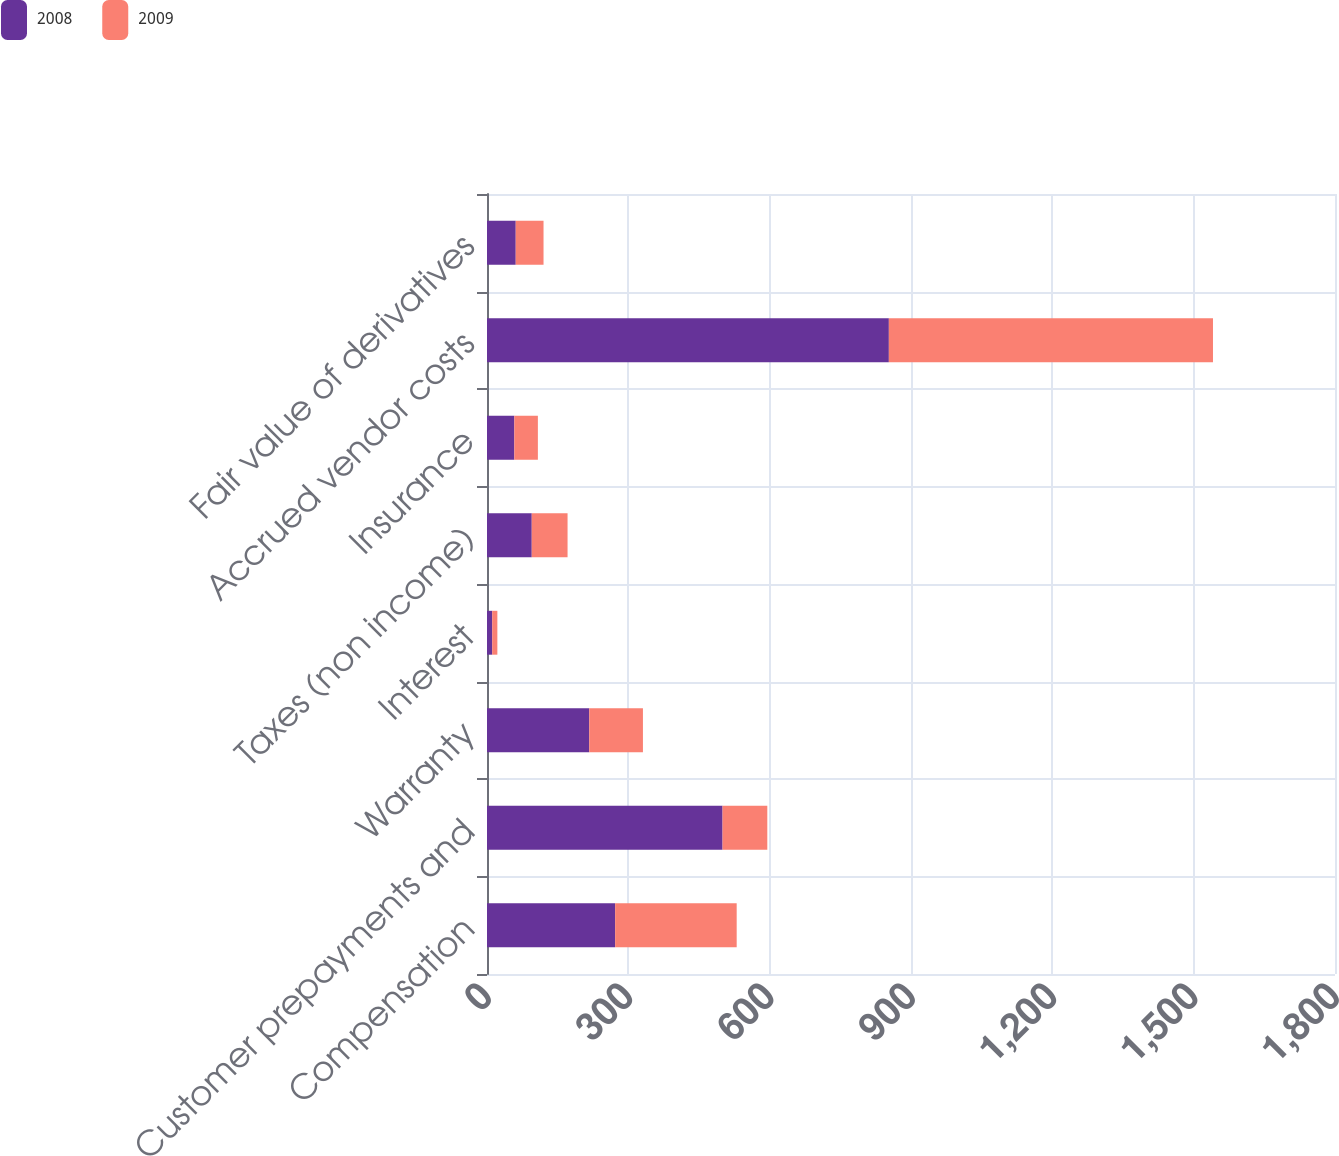Convert chart to OTSL. <chart><loc_0><loc_0><loc_500><loc_500><stacked_bar_chart><ecel><fcel>Compensation<fcel>Customer prepayments and<fcel>Warranty<fcel>Interest<fcel>Taxes (non income)<fcel>Insurance<fcel>Accrued vendor costs<fcel>Fair value of derivatives<nl><fcel>2008<fcel>272<fcel>500<fcel>217<fcel>11<fcel>95<fcel>58<fcel>853<fcel>61<nl><fcel>2009<fcel>258<fcel>95<fcel>114<fcel>11<fcel>76<fcel>50<fcel>688<fcel>59<nl></chart> 